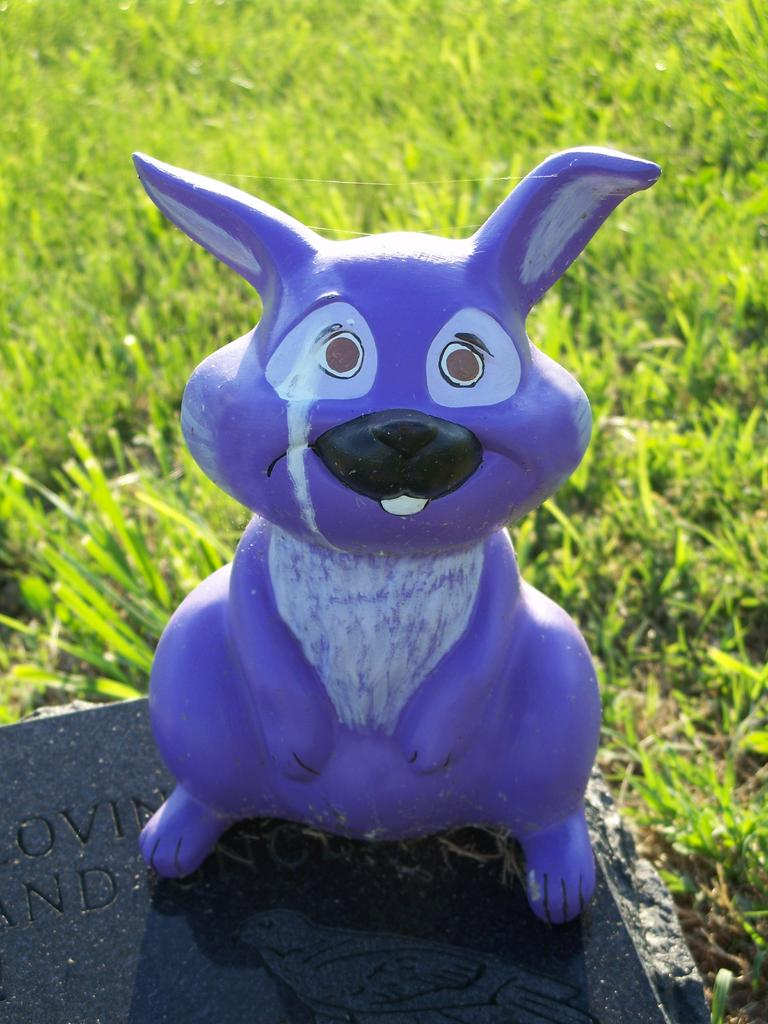What type of toy is on the table in the image? There is a toy rabbit on the table in the image. What can be seen on the backside of the image? There is grass visible on the backside of the image. How many cats are sitting on the lace in the image? There are no cats or lace present in the image. 